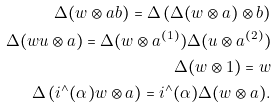Convert formula to latex. <formula><loc_0><loc_0><loc_500><loc_500>\Delta ( w \otimes a b ) = \Delta \left ( \Delta ( w \otimes a ) \otimes b \right ) \\ \Delta ( w u \otimes a ) = \Delta ( w \otimes a ^ { ( 1 ) } ) \Delta ( u \otimes a ^ { ( 2 ) } ) \\ \Delta ( w \otimes 1 ) = w \\ \Delta \left ( i ^ { \wedge } ( \alpha ) w \otimes a \right ) = i ^ { \wedge } ( \alpha ) \Delta ( w \otimes a ) .</formula> 